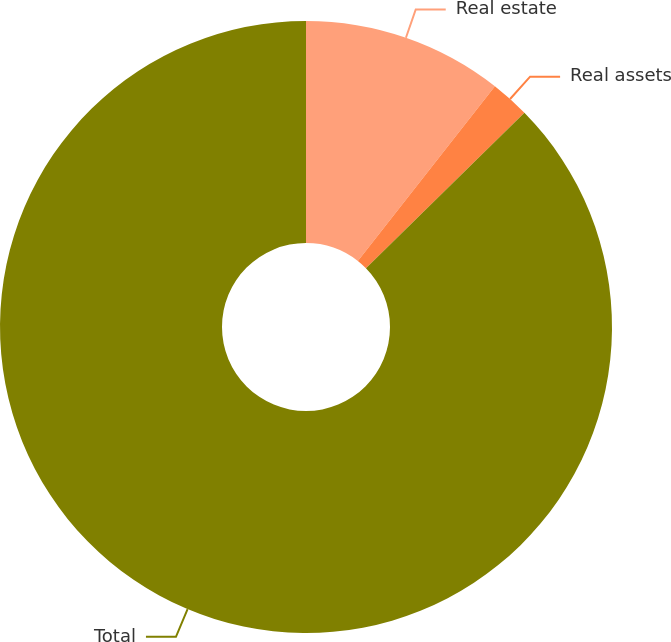<chart> <loc_0><loc_0><loc_500><loc_500><pie_chart><fcel>Real estate<fcel>Real assets<fcel>Total<nl><fcel>10.59%<fcel>2.06%<fcel>87.35%<nl></chart> 